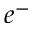Convert formula to latex. <formula><loc_0><loc_0><loc_500><loc_500>e ^ { - }</formula> 